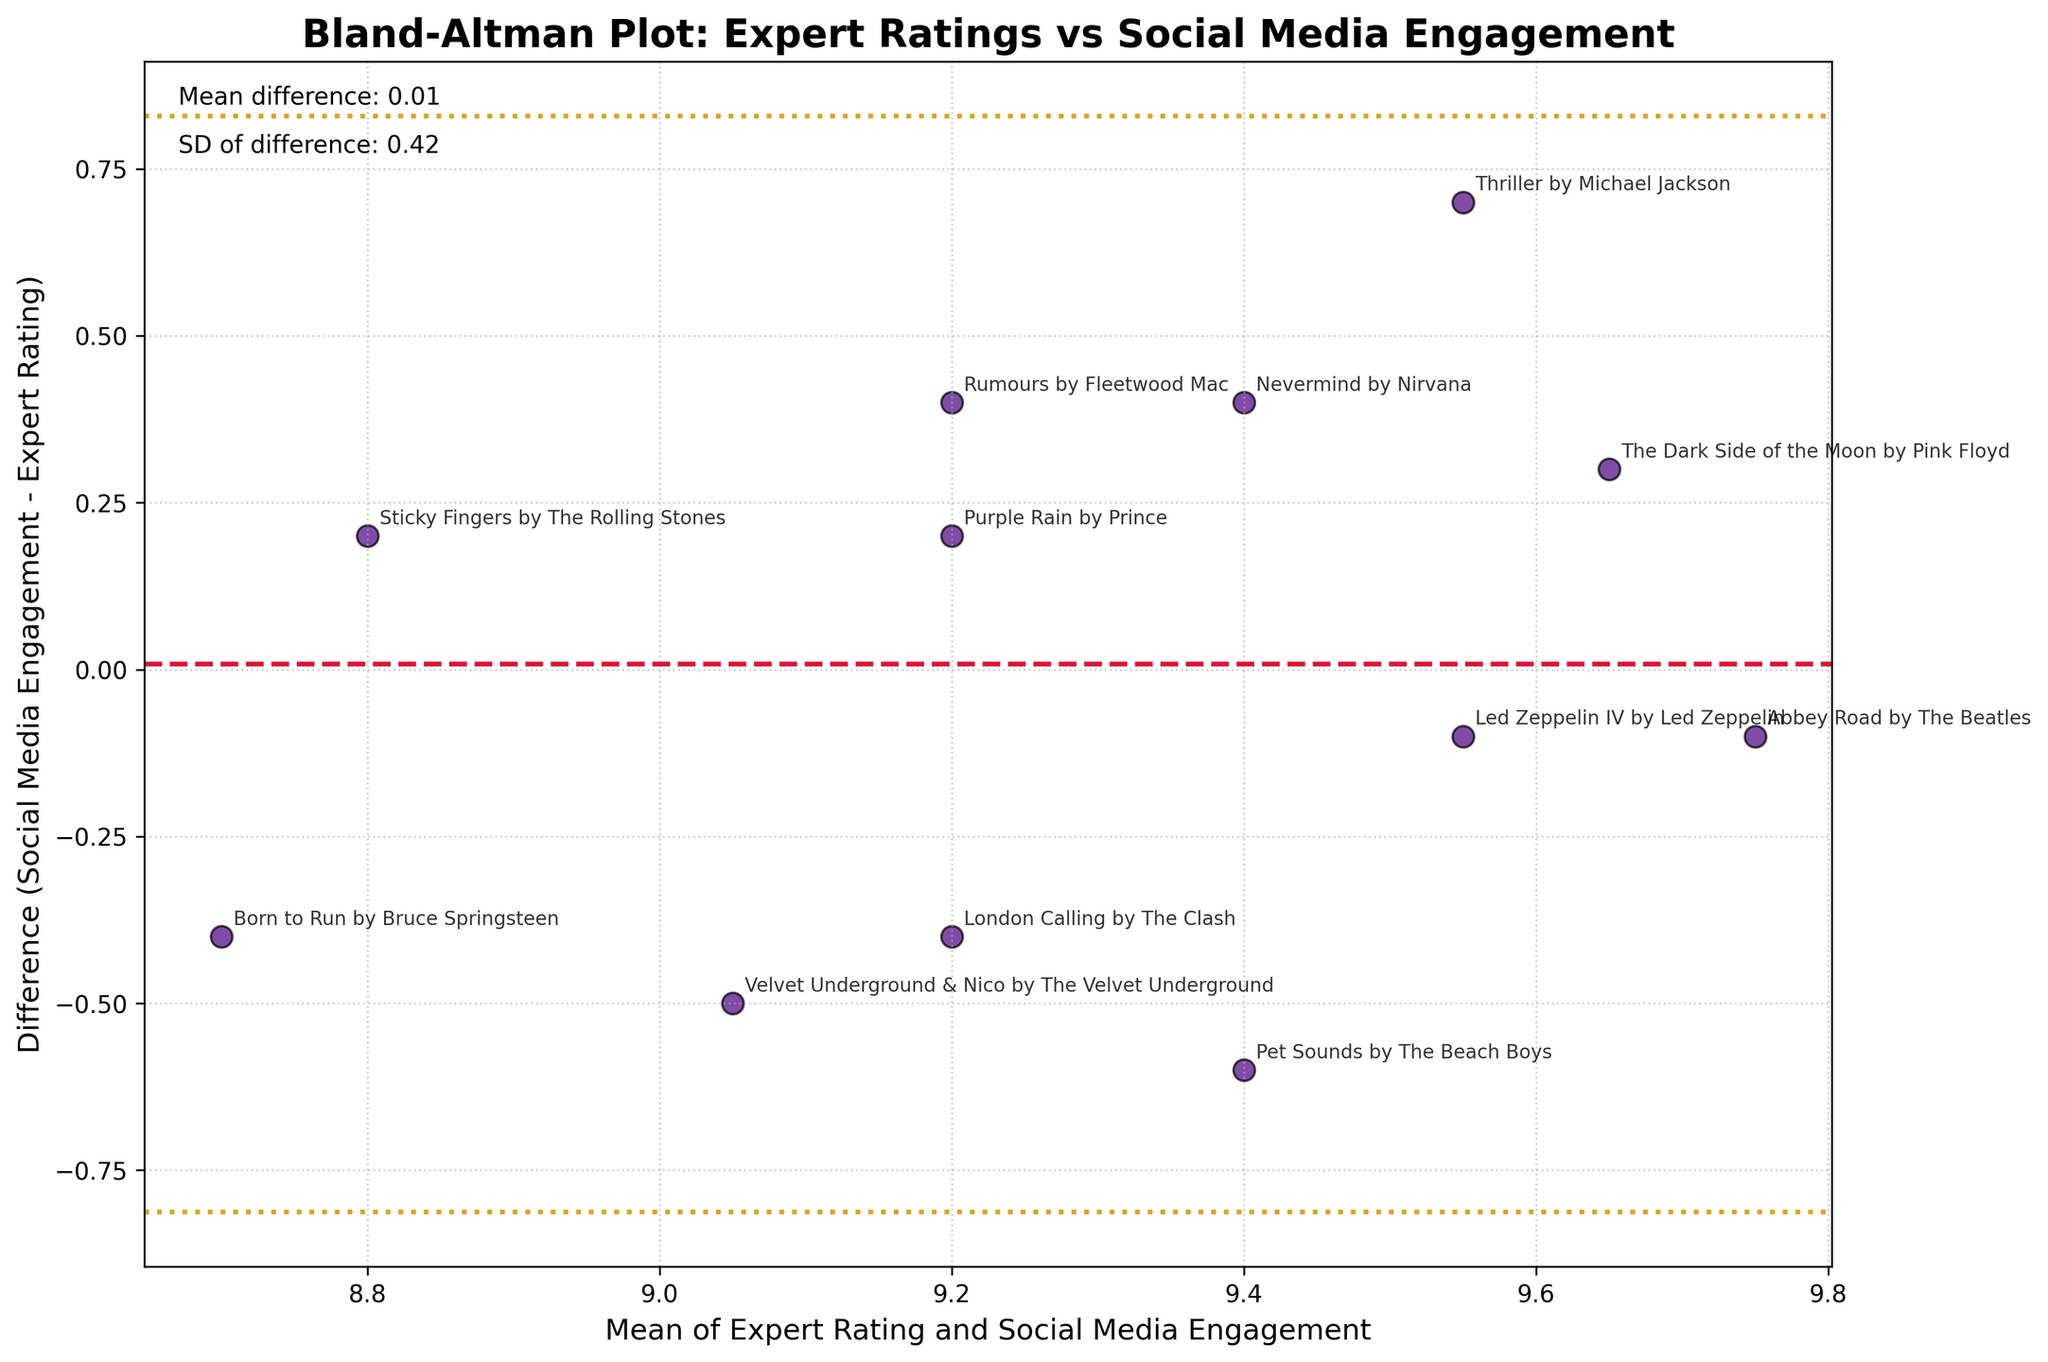What is the title of the plot? The title of the plot is displayed at the top of the figure and reads "Bland-Altman Plot: Expert Ratings vs Social Media Engagement."
Answer: Bland-Altman Plot: Expert Ratings vs Social Media Engagement How many data points are plotted in the figure? The number of data points can be determined by counting the number of distinct scatter points in the plot. Each point represents an album.
Answer: 12 What is the y-axis label of the plot? The y-axis label is present on the vertical axis of the plot and reads "Difference (Social Media Engagement - Expert Rating)."
Answer: Difference (Social Media Engagement - Expert Rating) Which album cover has the largest positive difference between social media engagement and expert rating? To find this, identify the scatter point located highest on the y-axis. This point represents the album "Thriller" by Michael Jackson.
Answer: "Thriller" by Michael Jackson What is the mean difference between social media engagement and expert rating? The mean difference is indicated by a horizontal dashed line on the plot and is also noted in the plot with text. It is shown as a horizontal line at approximately 0.02 and explicitly stated in the text.
Answer: 0.02 Which album cover has a mean value of around 9.475? To find this, look for the point closest to 9.475 on the x-axis. This data point needs to be identified by cross-referencing with the annotations on the plot. The closest album is "Abbey Road" by The Beatles.
Answer: "Abbey Road" by The Beatles What is the standard deviation of the difference data? The standard deviation of the difference is given in the text on the plot. This information is found near the title and is written explicitly.
Answer: 0.41 Which album has a mean rating and engagement value of approximately 9.0 and a negative difference? Locate the scatter point near a mean value of about 9.0 on the x-axis. The album with a negative difference at this mean value is "London Calling" by The Clash.
Answer: "London Calling" by The Clash What are the upper and lower 95% limits of agreement for the difference? The 95% limits of agreement are indicated by the dotted lines on the plot, which can be approximated from the plot and the text in the figure. The upper limit is approximately 0.83, and the lower limit is approximately -0.79.
Answer: Upper: 0.83, Lower: -0.79 